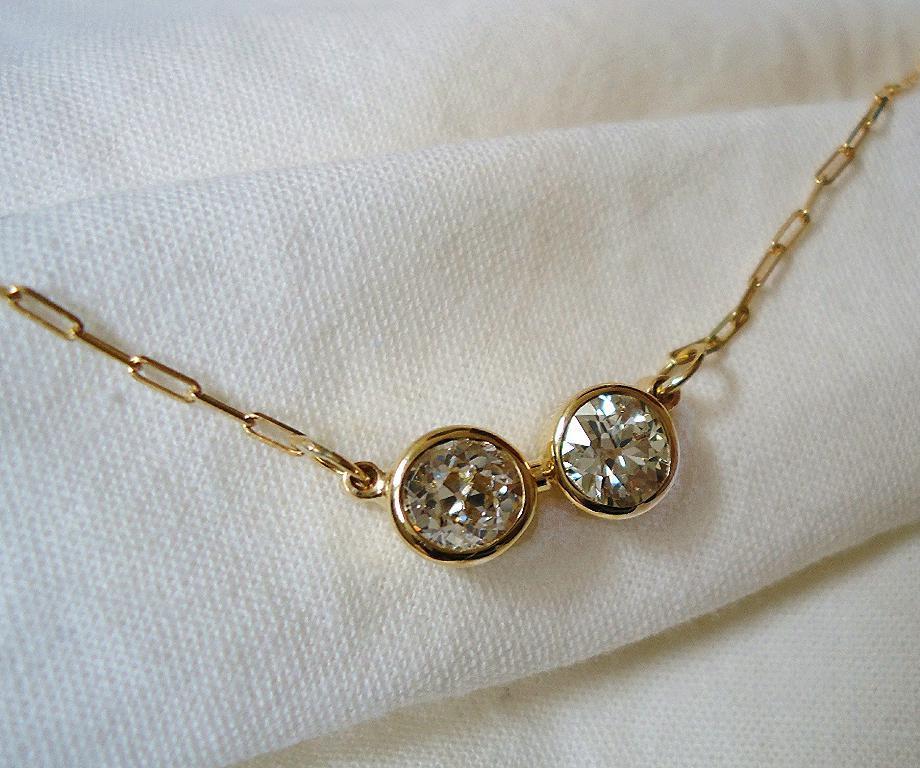In one or two sentences, can you explain what this image depicts? In the picture I can see a golden color ornament placed on the white color cloth. 